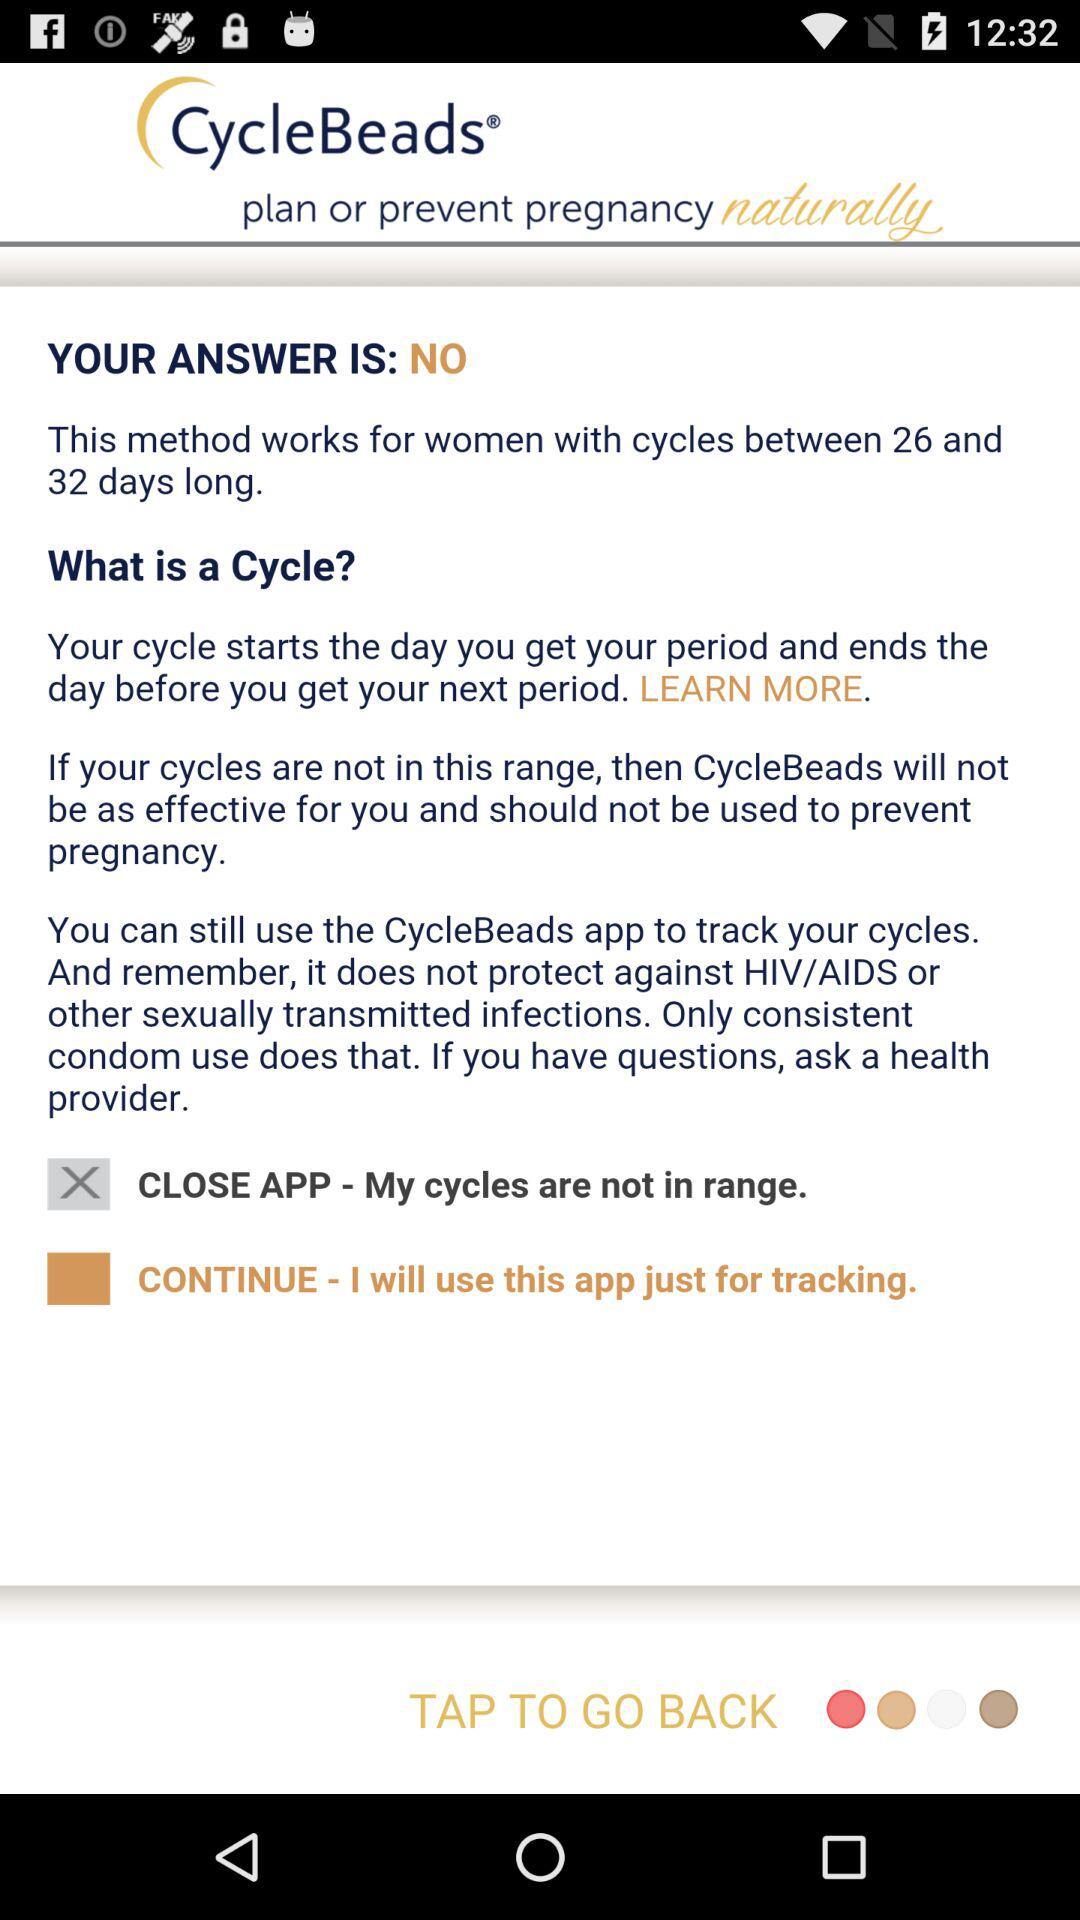How many days longer is the maximum cycle length than the minimum cycle length?
Answer the question using a single word or phrase. 6 